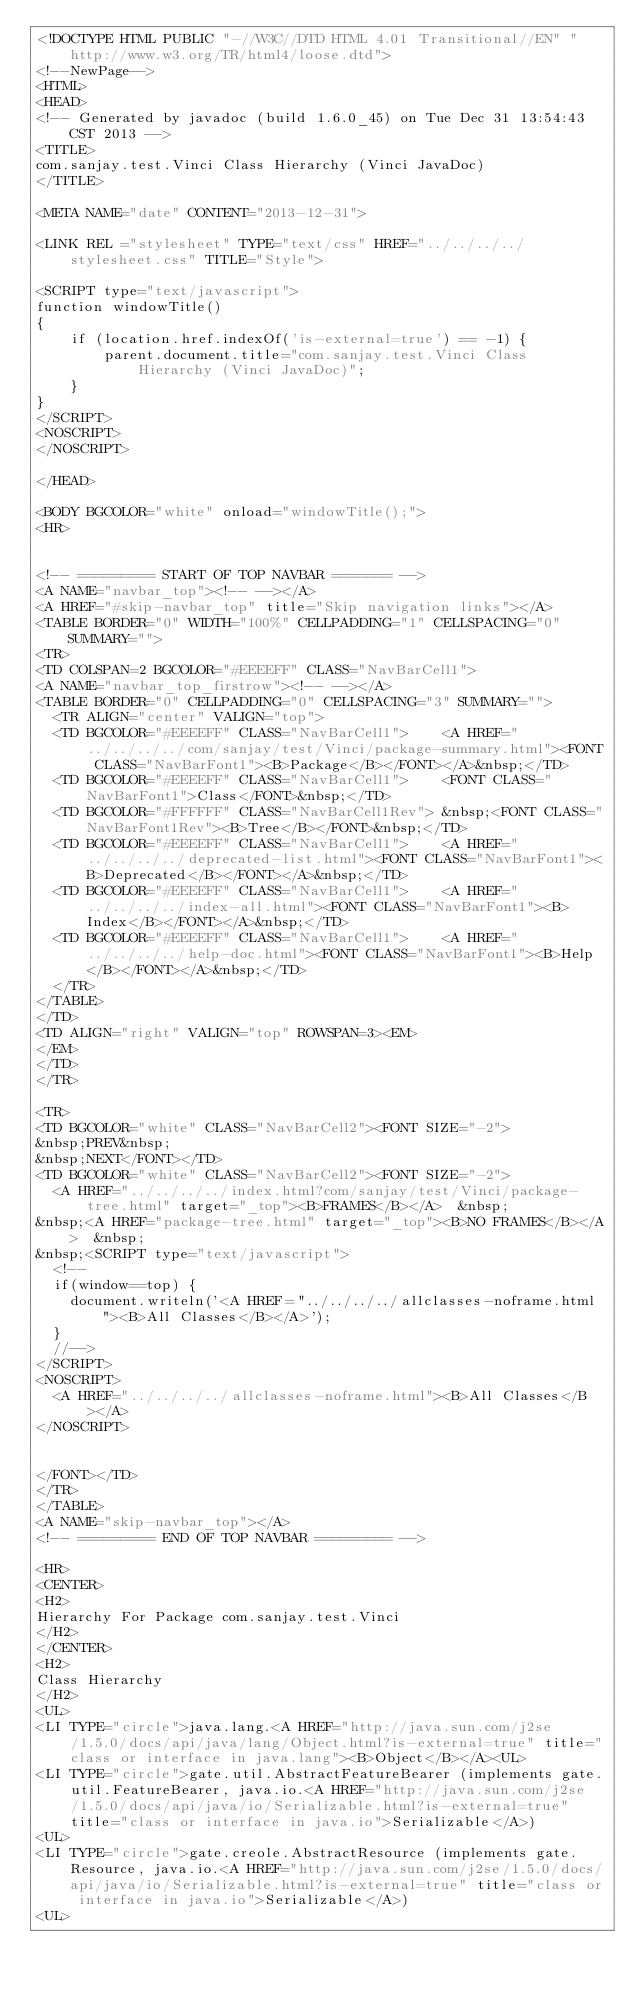Convert code to text. <code><loc_0><loc_0><loc_500><loc_500><_HTML_><!DOCTYPE HTML PUBLIC "-//W3C//DTD HTML 4.01 Transitional//EN" "http://www.w3.org/TR/html4/loose.dtd">
<!--NewPage-->
<HTML>
<HEAD>
<!-- Generated by javadoc (build 1.6.0_45) on Tue Dec 31 13:54:43 CST 2013 -->
<TITLE>
com.sanjay.test.Vinci Class Hierarchy (Vinci JavaDoc)
</TITLE>

<META NAME="date" CONTENT="2013-12-31">

<LINK REL ="stylesheet" TYPE="text/css" HREF="../../../../stylesheet.css" TITLE="Style">

<SCRIPT type="text/javascript">
function windowTitle()
{
    if (location.href.indexOf('is-external=true') == -1) {
        parent.document.title="com.sanjay.test.Vinci Class Hierarchy (Vinci JavaDoc)";
    }
}
</SCRIPT>
<NOSCRIPT>
</NOSCRIPT>

</HEAD>

<BODY BGCOLOR="white" onload="windowTitle();">
<HR>


<!-- ========= START OF TOP NAVBAR ======= -->
<A NAME="navbar_top"><!-- --></A>
<A HREF="#skip-navbar_top" title="Skip navigation links"></A>
<TABLE BORDER="0" WIDTH="100%" CELLPADDING="1" CELLSPACING="0" SUMMARY="">
<TR>
<TD COLSPAN=2 BGCOLOR="#EEEEFF" CLASS="NavBarCell1">
<A NAME="navbar_top_firstrow"><!-- --></A>
<TABLE BORDER="0" CELLPADDING="0" CELLSPACING="3" SUMMARY="">
  <TR ALIGN="center" VALIGN="top">
  <TD BGCOLOR="#EEEEFF" CLASS="NavBarCell1">    <A HREF="../../../../com/sanjay/test/Vinci/package-summary.html"><FONT CLASS="NavBarFont1"><B>Package</B></FONT></A>&nbsp;</TD>
  <TD BGCOLOR="#EEEEFF" CLASS="NavBarCell1">    <FONT CLASS="NavBarFont1">Class</FONT>&nbsp;</TD>
  <TD BGCOLOR="#FFFFFF" CLASS="NavBarCell1Rev"> &nbsp;<FONT CLASS="NavBarFont1Rev"><B>Tree</B></FONT>&nbsp;</TD>
  <TD BGCOLOR="#EEEEFF" CLASS="NavBarCell1">    <A HREF="../../../../deprecated-list.html"><FONT CLASS="NavBarFont1"><B>Deprecated</B></FONT></A>&nbsp;</TD>
  <TD BGCOLOR="#EEEEFF" CLASS="NavBarCell1">    <A HREF="../../../../index-all.html"><FONT CLASS="NavBarFont1"><B>Index</B></FONT></A>&nbsp;</TD>
  <TD BGCOLOR="#EEEEFF" CLASS="NavBarCell1">    <A HREF="../../../../help-doc.html"><FONT CLASS="NavBarFont1"><B>Help</B></FONT></A>&nbsp;</TD>
  </TR>
</TABLE>
</TD>
<TD ALIGN="right" VALIGN="top" ROWSPAN=3><EM>
</EM>
</TD>
</TR>

<TR>
<TD BGCOLOR="white" CLASS="NavBarCell2"><FONT SIZE="-2">
&nbsp;PREV&nbsp;
&nbsp;NEXT</FONT></TD>
<TD BGCOLOR="white" CLASS="NavBarCell2"><FONT SIZE="-2">
  <A HREF="../../../../index.html?com/sanjay/test/Vinci/package-tree.html" target="_top"><B>FRAMES</B></A>  &nbsp;
&nbsp;<A HREF="package-tree.html" target="_top"><B>NO FRAMES</B></A>  &nbsp;
&nbsp;<SCRIPT type="text/javascript">
  <!--
  if(window==top) {
    document.writeln('<A HREF="../../../../allclasses-noframe.html"><B>All Classes</B></A>');
  }
  //-->
</SCRIPT>
<NOSCRIPT>
  <A HREF="../../../../allclasses-noframe.html"><B>All Classes</B></A>
</NOSCRIPT>


</FONT></TD>
</TR>
</TABLE>
<A NAME="skip-navbar_top"></A>
<!-- ========= END OF TOP NAVBAR ========= -->

<HR>
<CENTER>
<H2>
Hierarchy For Package com.sanjay.test.Vinci
</H2>
</CENTER>
<H2>
Class Hierarchy
</H2>
<UL>
<LI TYPE="circle">java.lang.<A HREF="http://java.sun.com/j2se/1.5.0/docs/api/java/lang/Object.html?is-external=true" title="class or interface in java.lang"><B>Object</B></A><UL>
<LI TYPE="circle">gate.util.AbstractFeatureBearer (implements gate.util.FeatureBearer, java.io.<A HREF="http://java.sun.com/j2se/1.5.0/docs/api/java/io/Serializable.html?is-external=true" title="class or interface in java.io">Serializable</A>)
<UL>
<LI TYPE="circle">gate.creole.AbstractResource (implements gate.Resource, java.io.<A HREF="http://java.sun.com/j2se/1.5.0/docs/api/java/io/Serializable.html?is-external=true" title="class or interface in java.io">Serializable</A>)
<UL></code> 